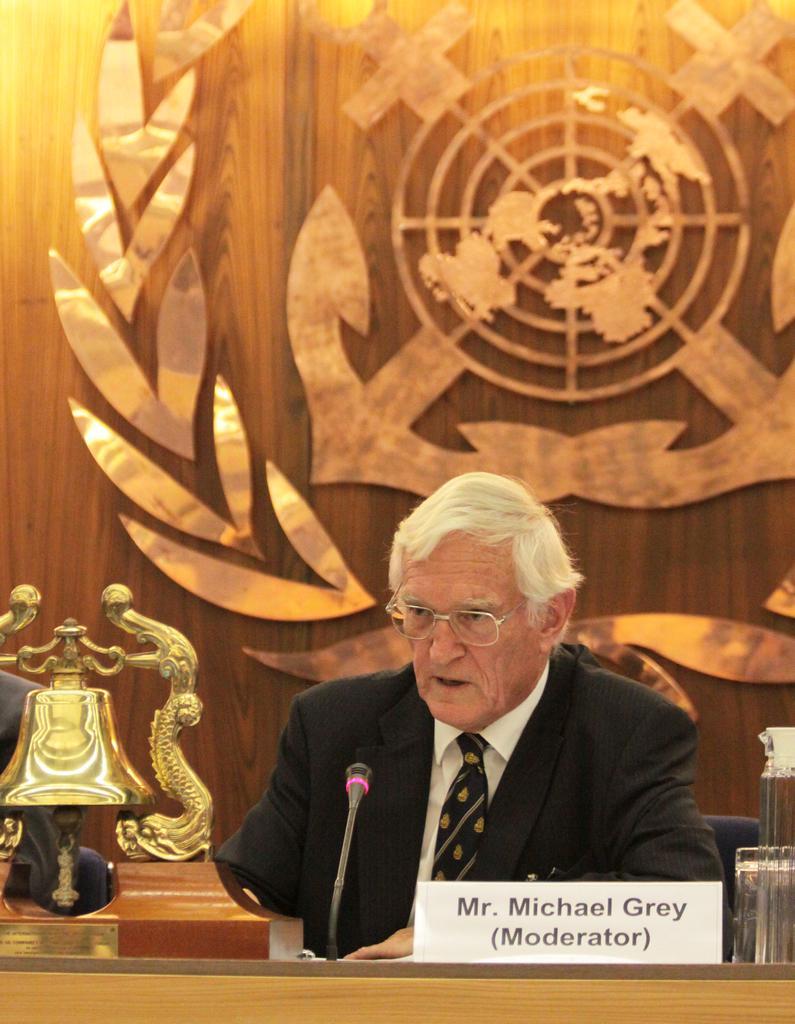How would you summarize this image in a sentence or two? In this image, there is a person wearing clothes and sitting on the chair in front of the table contains a mic. There is logo at the top of the image. There is a bell in the bottom left of the image. 